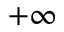Convert formula to latex. <formula><loc_0><loc_0><loc_500><loc_500>+ \infty</formula> 